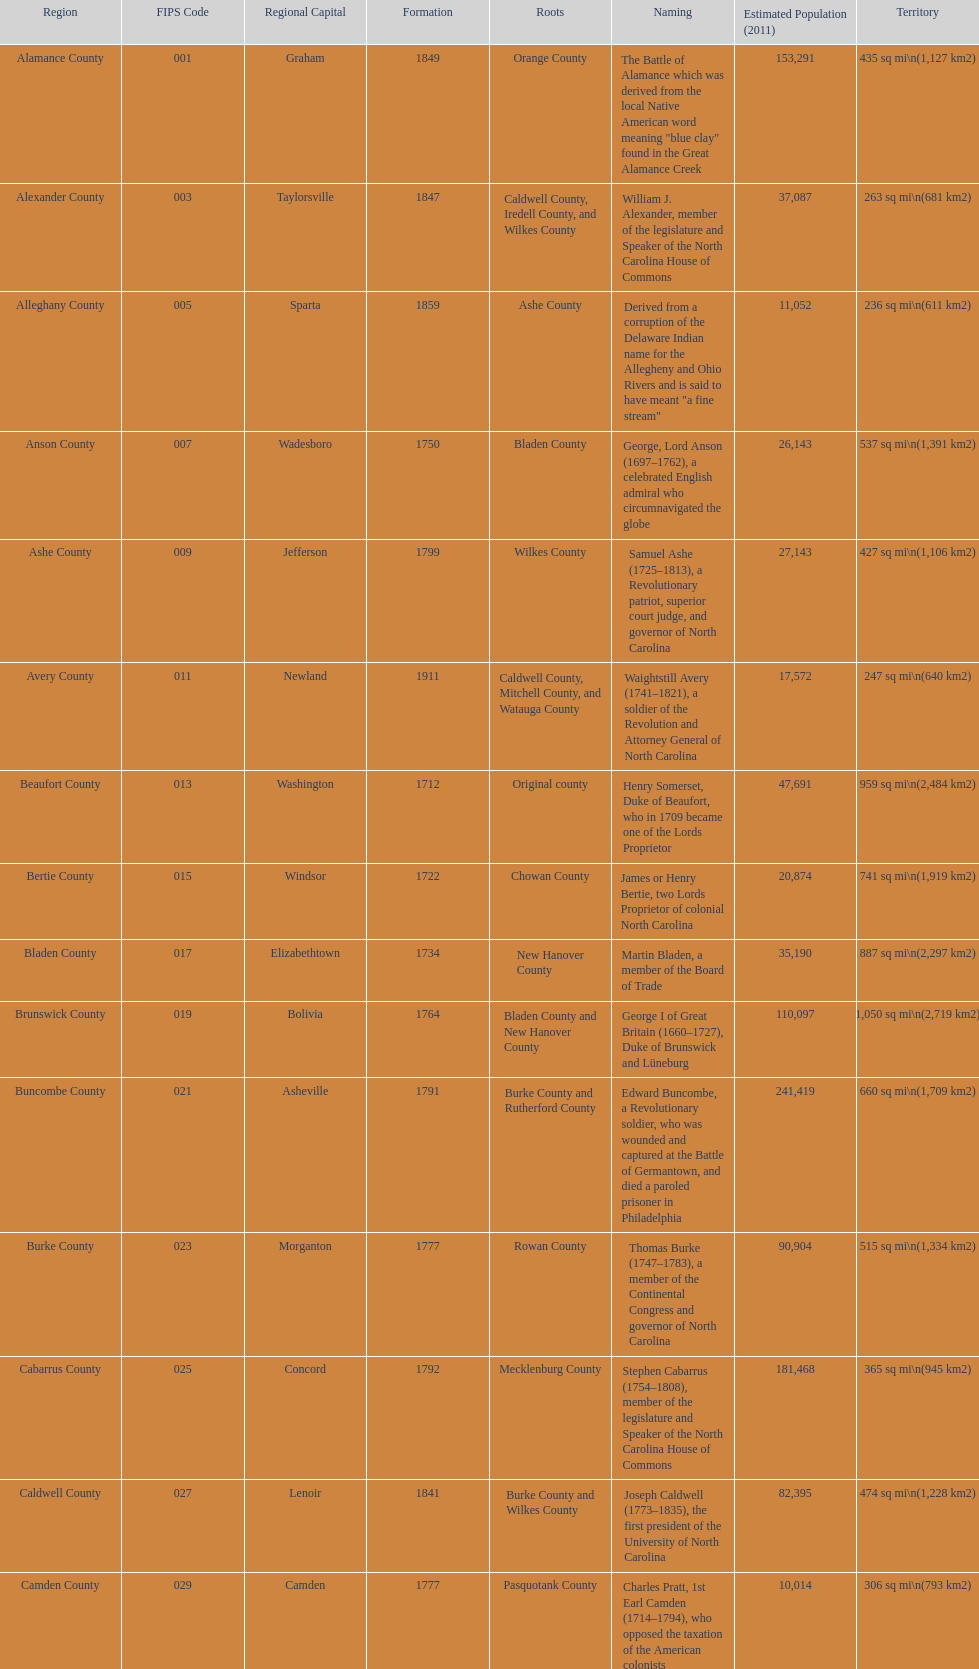What is the total number of counties listed? 100. 